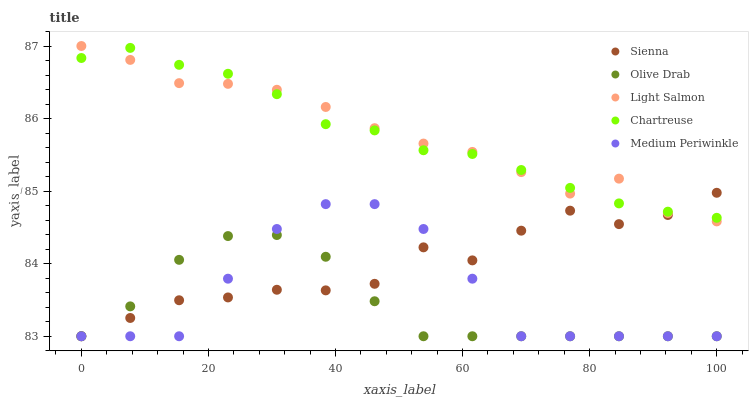Does Olive Drab have the minimum area under the curve?
Answer yes or no. Yes. Does Light Salmon have the maximum area under the curve?
Answer yes or no. Yes. Does Medium Periwinkle have the minimum area under the curve?
Answer yes or no. No. Does Medium Periwinkle have the maximum area under the curve?
Answer yes or no. No. Is Chartreuse the smoothest?
Answer yes or no. Yes. Is Sienna the roughest?
Answer yes or no. Yes. Is Light Salmon the smoothest?
Answer yes or no. No. Is Light Salmon the roughest?
Answer yes or no. No. Does Sienna have the lowest value?
Answer yes or no. Yes. Does Light Salmon have the lowest value?
Answer yes or no. No. Does Light Salmon have the highest value?
Answer yes or no. Yes. Does Medium Periwinkle have the highest value?
Answer yes or no. No. Is Medium Periwinkle less than Chartreuse?
Answer yes or no. Yes. Is Light Salmon greater than Olive Drab?
Answer yes or no. Yes. Does Chartreuse intersect Light Salmon?
Answer yes or no. Yes. Is Chartreuse less than Light Salmon?
Answer yes or no. No. Is Chartreuse greater than Light Salmon?
Answer yes or no. No. Does Medium Periwinkle intersect Chartreuse?
Answer yes or no. No. 